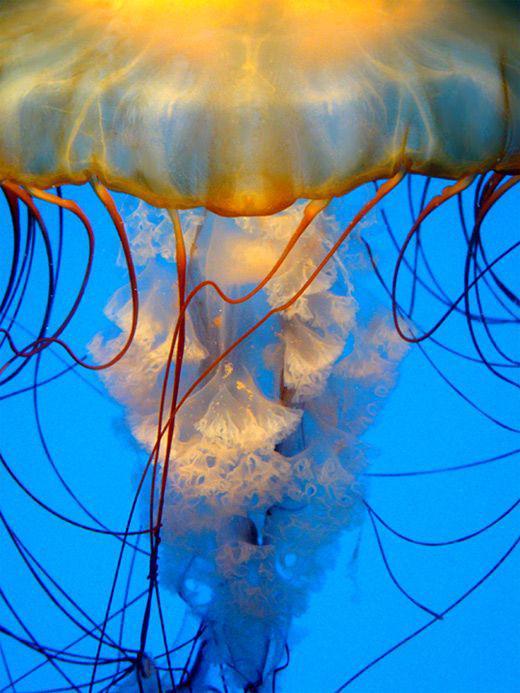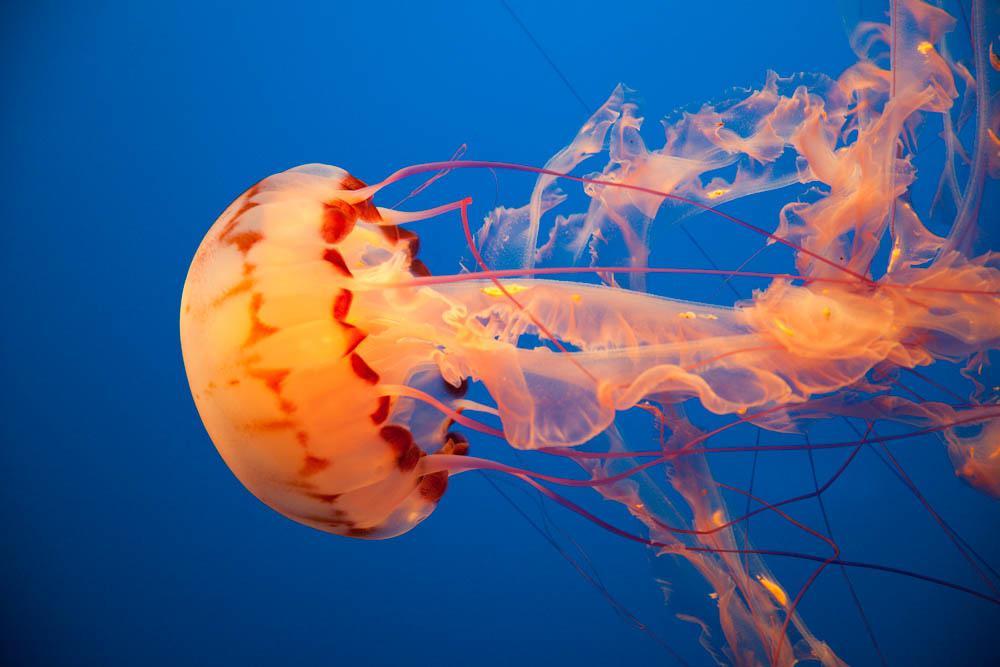The first image is the image on the left, the second image is the image on the right. Analyze the images presented: Is the assertion "One of the jellyfish is heading in a horizontal direction." valid? Answer yes or no. Yes. The first image is the image on the left, the second image is the image on the right. Analyze the images presented: Is the assertion "Each image contains one jellyfish with an orange 'cap', and the lefthand jellyfish has an upright 'cap' with tentacles trailing downward." valid? Answer yes or no. Yes. 